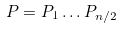<formula> <loc_0><loc_0><loc_500><loc_500>P = P _ { 1 } \dots P _ { n / 2 }</formula> 